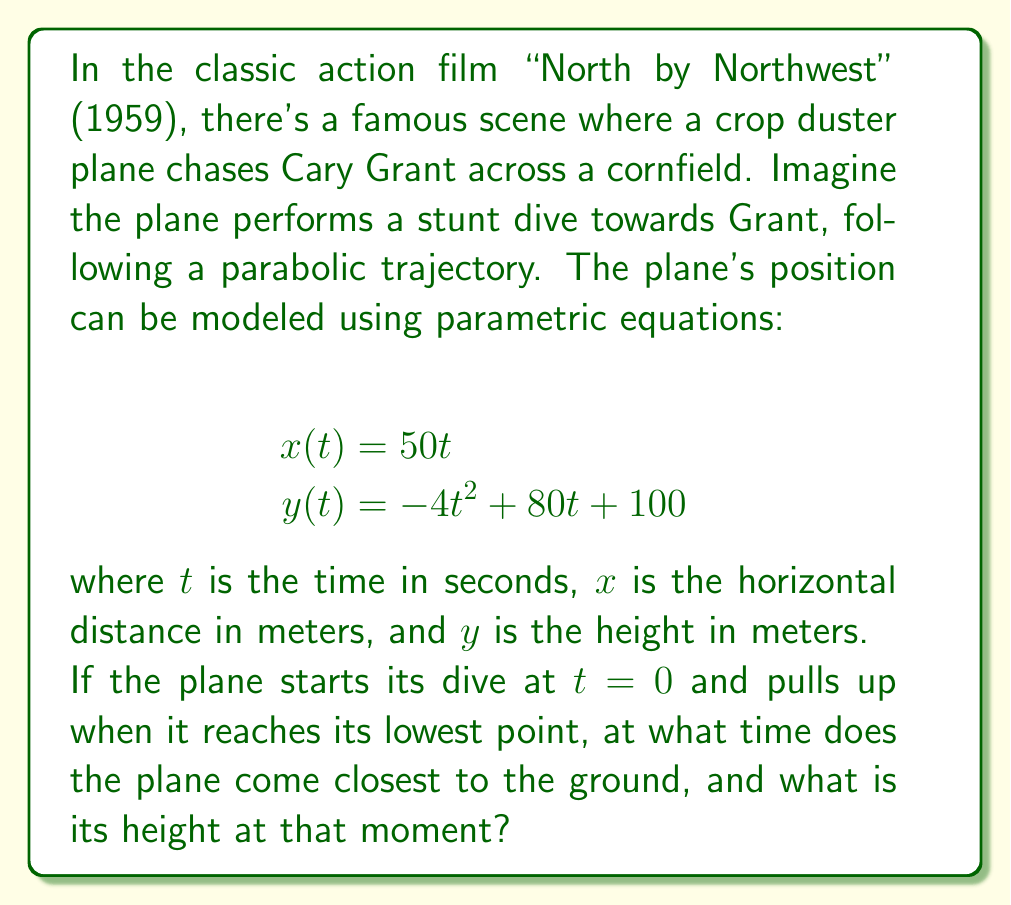Show me your answer to this math problem. To solve this problem, we need to follow these steps:

1) The plane's height is given by the equation $y(t) = -4t^2 + 80t + 100$. This is a parabolic function.

2) The lowest point of a parabola occurs at its vertex. To find the vertex, we need to find the t-value where the derivative of y(t) is zero.

3) Let's find the derivative of y(t):
   $$y'(t) = -8t + 80$$

4) Set the derivative to zero and solve for t:
   $$-8t + 80 = 0$$
   $$-8t = -80$$
   $$t = 10$$

5) This means the plane reaches its lowest point at t = 10 seconds.

6) To find the height at this point, we substitute t = 10 into the original y(t) equation:

   $$y(10) = -4(10)^2 + 80(10) + 100$$
   $$= -400 + 800 + 100$$
   $$= 500$$

Therefore, the plane comes closest to the ground after 10 seconds, at a height of 500 meters.
Answer: Time: 10 seconds; Height: 500 meters 